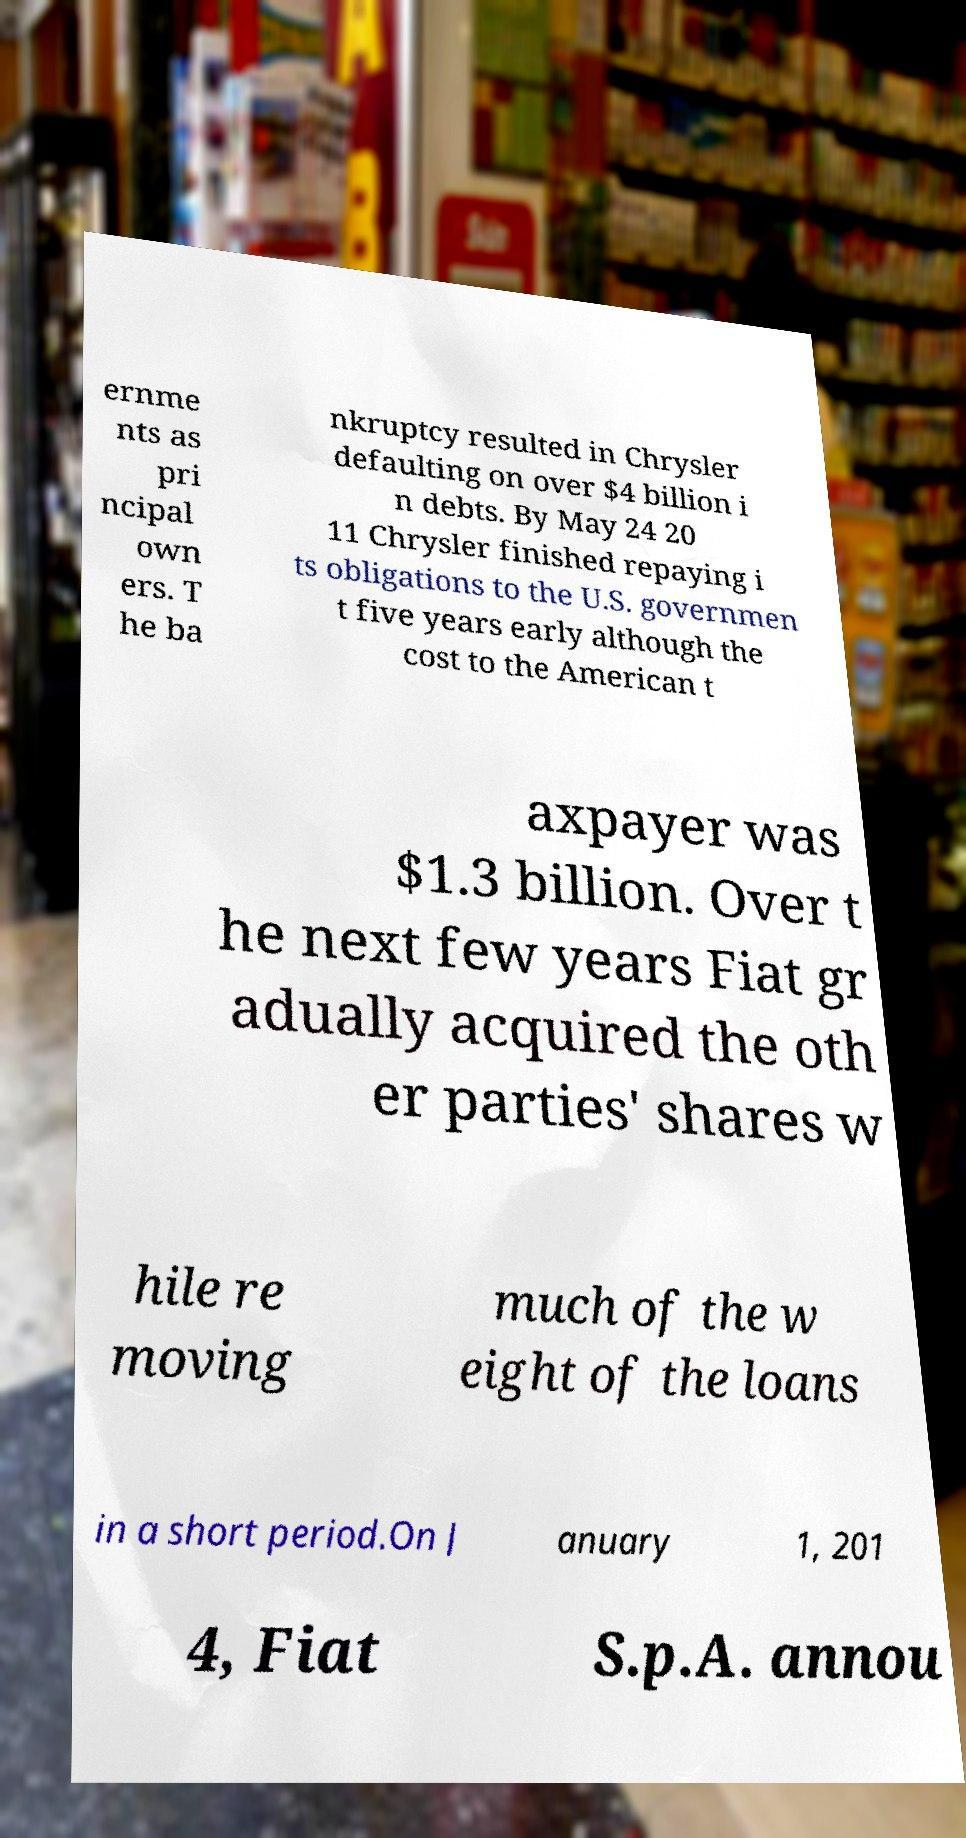Please identify and transcribe the text found in this image. ernme nts as pri ncipal own ers. T he ba nkruptcy resulted in Chrysler defaulting on over $4 billion i n debts. By May 24 20 11 Chrysler finished repaying i ts obligations to the U.S. governmen t five years early although the cost to the American t axpayer was $1.3 billion. Over t he next few years Fiat gr adually acquired the oth er parties' shares w hile re moving much of the w eight of the loans in a short period.On J anuary 1, 201 4, Fiat S.p.A. annou 